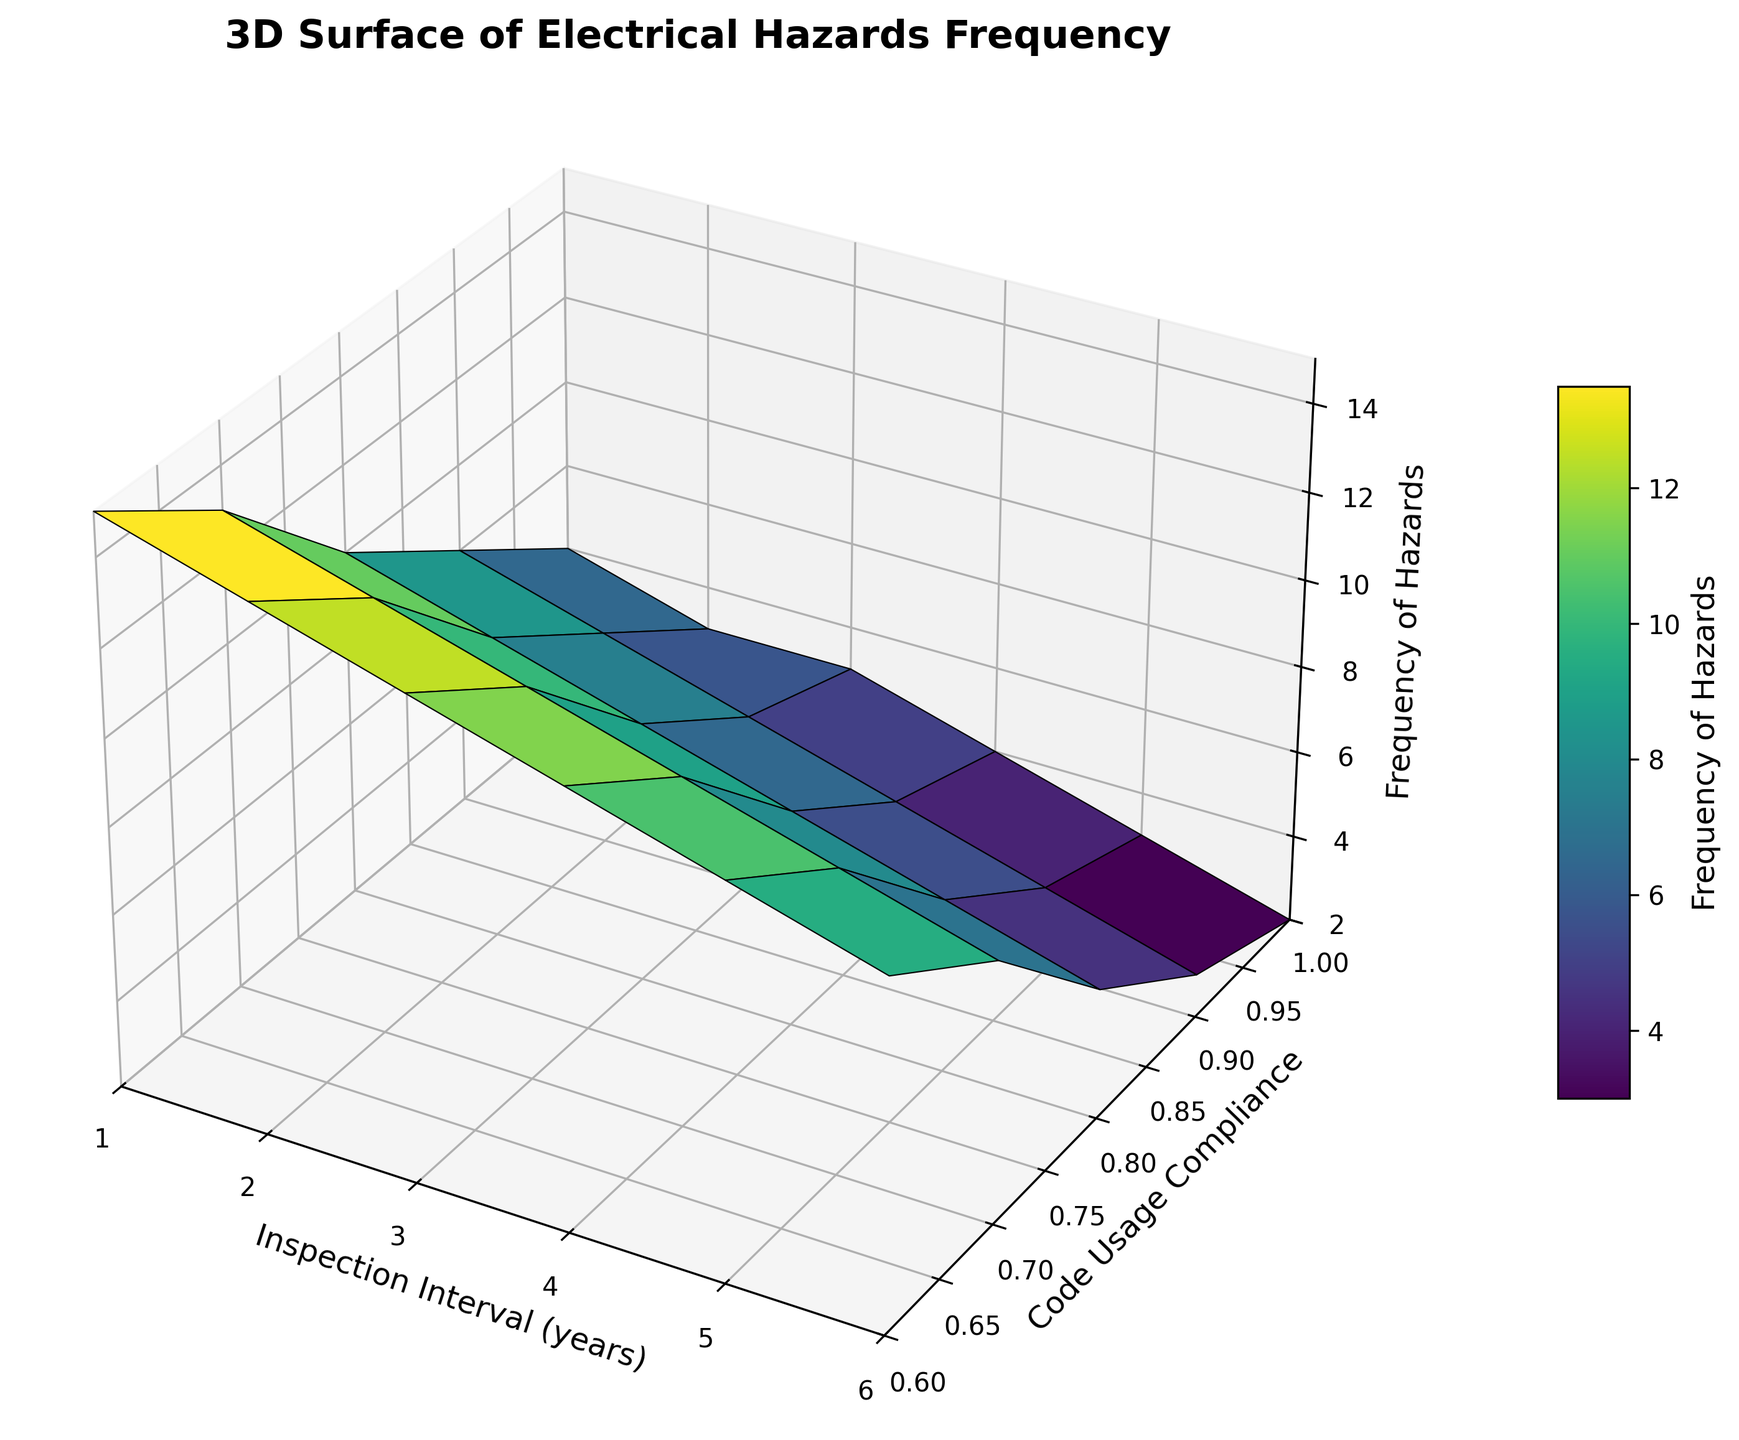What is the frequency of hazards when the inspection interval is 3 years and code usage compliance is 0.8? At an inspection interval of 3 years and a code usage compliance of 0.8, locate the corresponding Z value (frequency of hazards) on the surface plot.
Answer: 8 How does the frequency of hazards change as the inspection interval increases from 1 year to 5 years for code usage compliance of 1.0? Track the trend of Z values for code usage compliance of 1.0 as the inspection interval increases from 1 to 5 years. The frequency decreases from 6 to 3.
Answer: decreases What is the difference in frequency of hazards between inspection intervals of 2 years and 4 years when code usage compliance is 0.9? Find the Z values at 2 years (7) and 4 years (5) for code usage compliance of 0.9, then subtract the latter from the former: 7 - 5.
Answer: 2 Which combination of inspection interval and code usage compliance results in the lowest frequency of hazards? Identify the lowest Z value on the surface plot and find the corresponding X and Y values. Inspection interval of 6 years and code usage compliance of 1.0 yields the lowest frequency of 2.
Answer: 6 years, 1.0 compliance Is the frequency of hazards higher at an inspection interval of 4 years with 0.6 compliance or at 2 years with 0.8 compliance? Compare the Z values for 4 years with 0.6 compliance (12) and 2 years with 0.8 compliance (9).
Answer: 4 years, 0.6 compliance What trend do you observe in the frequency of hazards as code usage compliance increases from 0.6 to 1.0 for a constant inspection interval of 1 year? As code usage compliance increases from 0.6 to 1.0 for a 1-year inspection interval, the Z value (frequency of hazards) continuously decreases from 15 to 6.
Answer: decreases By how much does the frequency of hazards change when moving from an inspection interval of 5 years to 6 years with a constant code usage compliance of 0.7? Find the Z values for 5 years (9) and 6 years (8) with 0.7 compliance, then calculate the difference: 9 - 8.
Answer: 1 If code usage compliance is increased from 0.7 to 0.9 for an inspection interval of 3 years, how does the frequency of hazards change? Track the change in Z value from 0.7 compliance (11) to 0.9 compliance (6) for a 3-year inspection interval: 11 - 6.
Answer: decreases by 5 Which has a greater impact on reducing hazards: increasing code usage compliance or increasing the inspection interval? Compare the slopes along the code usage compliance axis and the inspection interval axis. The decrease in hazards is more pronounced with increasing code compliance.
Answer: code usage compliance 